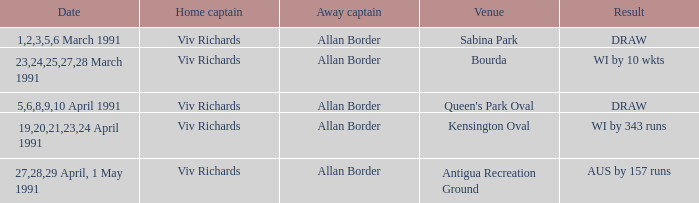What dates had matches at the venue Sabina Park? 1,2,3,5,6 March 1991. 